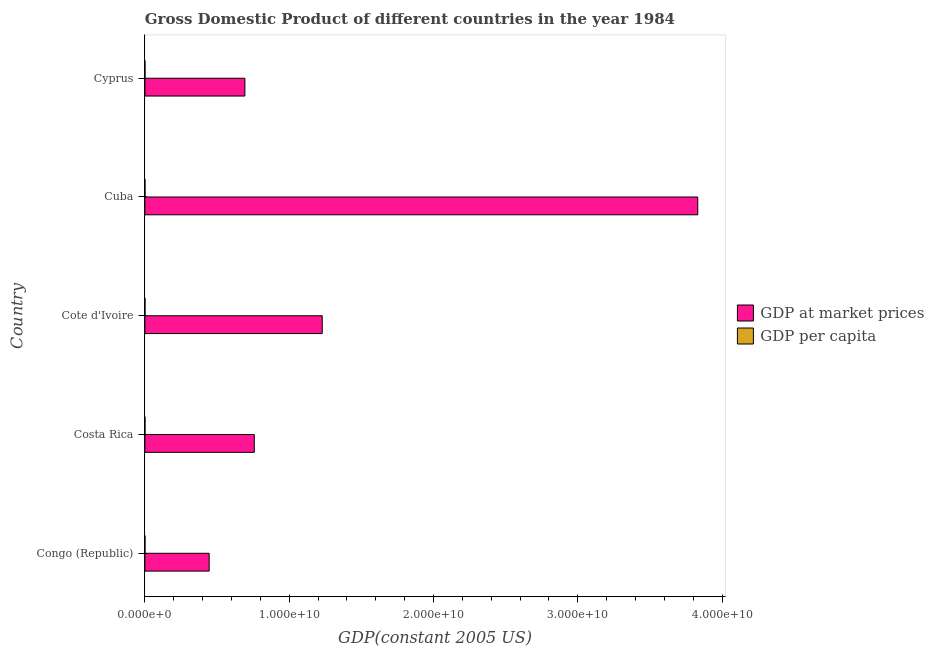How many bars are there on the 1st tick from the top?
Offer a very short reply. 2. How many bars are there on the 4th tick from the bottom?
Offer a terse response. 2. What is the label of the 5th group of bars from the top?
Your answer should be compact. Congo (Republic). What is the gdp at market prices in Congo (Republic)?
Your answer should be very brief. 4.45e+09. Across all countries, what is the maximum gdp at market prices?
Offer a very short reply. 3.83e+1. Across all countries, what is the minimum gdp per capita?
Your answer should be very brief. 1258.08. In which country was the gdp at market prices maximum?
Ensure brevity in your answer.  Cuba. In which country was the gdp per capita minimum?
Your response must be concise. Cote d'Ivoire. What is the total gdp per capita in the graph?
Your answer should be compact. 2.31e+04. What is the difference between the gdp per capita in Costa Rica and that in Cote d'Ivoire?
Make the answer very short. 1592.07. What is the difference between the gdp per capita in Costa Rica and the gdp at market prices in Cote d'Ivoire?
Give a very brief answer. -1.23e+1. What is the average gdp at market prices per country?
Keep it short and to the point. 1.39e+1. What is the difference between the gdp at market prices and gdp per capita in Cote d'Ivoire?
Make the answer very short. 1.23e+1. In how many countries, is the gdp per capita greater than 2000000000 US$?
Offer a very short reply. 0. What is the ratio of the gdp per capita in Cote d'Ivoire to that in Cuba?
Your answer should be very brief. 0.33. Is the gdp per capita in Costa Rica less than that in Cote d'Ivoire?
Ensure brevity in your answer.  No. Is the difference between the gdp per capita in Cote d'Ivoire and Cyprus greater than the difference between the gdp at market prices in Cote d'Ivoire and Cyprus?
Keep it short and to the point. No. What is the difference between the highest and the second highest gdp at market prices?
Your answer should be compact. 2.60e+1. What is the difference between the highest and the lowest gdp at market prices?
Ensure brevity in your answer.  3.39e+1. Is the sum of the gdp at market prices in Cuba and Cyprus greater than the maximum gdp per capita across all countries?
Your answer should be compact. Yes. What does the 1st bar from the top in Cyprus represents?
Your response must be concise. GDP per capita. What does the 2nd bar from the bottom in Congo (Republic) represents?
Keep it short and to the point. GDP per capita. How many bars are there?
Give a very brief answer. 10. Are all the bars in the graph horizontal?
Provide a short and direct response. Yes. How many countries are there in the graph?
Your answer should be very brief. 5. What is the difference between two consecutive major ticks on the X-axis?
Give a very brief answer. 1.00e+1. Are the values on the major ticks of X-axis written in scientific E-notation?
Your answer should be very brief. Yes. Does the graph contain any zero values?
Give a very brief answer. No. Does the graph contain grids?
Make the answer very short. No. Where does the legend appear in the graph?
Your answer should be very brief. Center right. How many legend labels are there?
Offer a terse response. 2. What is the title of the graph?
Ensure brevity in your answer.  Gross Domestic Product of different countries in the year 1984. What is the label or title of the X-axis?
Offer a very short reply. GDP(constant 2005 US). What is the GDP(constant 2005 US) of GDP at market prices in Congo (Republic)?
Your response must be concise. 4.45e+09. What is the GDP(constant 2005 US) in GDP per capita in Congo (Republic)?
Provide a short and direct response. 2198.63. What is the GDP(constant 2005 US) of GDP at market prices in Costa Rica?
Keep it short and to the point. 7.58e+09. What is the GDP(constant 2005 US) in GDP per capita in Costa Rica?
Offer a terse response. 2850.16. What is the GDP(constant 2005 US) in GDP at market prices in Cote d'Ivoire?
Your response must be concise. 1.23e+1. What is the GDP(constant 2005 US) in GDP per capita in Cote d'Ivoire?
Your answer should be very brief. 1258.08. What is the GDP(constant 2005 US) in GDP at market prices in Cuba?
Your response must be concise. 3.83e+1. What is the GDP(constant 2005 US) of GDP per capita in Cuba?
Your response must be concise. 3825.47. What is the GDP(constant 2005 US) in GDP at market prices in Cyprus?
Ensure brevity in your answer.  6.93e+09. What is the GDP(constant 2005 US) in GDP per capita in Cyprus?
Ensure brevity in your answer.  1.30e+04. Across all countries, what is the maximum GDP(constant 2005 US) of GDP at market prices?
Your answer should be very brief. 3.83e+1. Across all countries, what is the maximum GDP(constant 2005 US) in GDP per capita?
Your response must be concise. 1.30e+04. Across all countries, what is the minimum GDP(constant 2005 US) of GDP at market prices?
Keep it short and to the point. 4.45e+09. Across all countries, what is the minimum GDP(constant 2005 US) of GDP per capita?
Give a very brief answer. 1258.08. What is the total GDP(constant 2005 US) in GDP at market prices in the graph?
Your answer should be compact. 6.96e+1. What is the total GDP(constant 2005 US) of GDP per capita in the graph?
Offer a terse response. 2.31e+04. What is the difference between the GDP(constant 2005 US) of GDP at market prices in Congo (Republic) and that in Costa Rica?
Your response must be concise. -3.13e+09. What is the difference between the GDP(constant 2005 US) of GDP per capita in Congo (Republic) and that in Costa Rica?
Offer a very short reply. -651.53. What is the difference between the GDP(constant 2005 US) in GDP at market prices in Congo (Republic) and that in Cote d'Ivoire?
Offer a terse response. -7.84e+09. What is the difference between the GDP(constant 2005 US) in GDP per capita in Congo (Republic) and that in Cote d'Ivoire?
Keep it short and to the point. 940.54. What is the difference between the GDP(constant 2005 US) of GDP at market prices in Congo (Republic) and that in Cuba?
Make the answer very short. -3.39e+1. What is the difference between the GDP(constant 2005 US) in GDP per capita in Congo (Republic) and that in Cuba?
Provide a succinct answer. -1626.84. What is the difference between the GDP(constant 2005 US) of GDP at market prices in Congo (Republic) and that in Cyprus?
Provide a short and direct response. -2.48e+09. What is the difference between the GDP(constant 2005 US) in GDP per capita in Congo (Republic) and that in Cyprus?
Give a very brief answer. -1.08e+04. What is the difference between the GDP(constant 2005 US) in GDP at market prices in Costa Rica and that in Cote d'Ivoire?
Give a very brief answer. -4.71e+09. What is the difference between the GDP(constant 2005 US) in GDP per capita in Costa Rica and that in Cote d'Ivoire?
Provide a short and direct response. 1592.07. What is the difference between the GDP(constant 2005 US) of GDP at market prices in Costa Rica and that in Cuba?
Your answer should be very brief. -3.07e+1. What is the difference between the GDP(constant 2005 US) in GDP per capita in Costa Rica and that in Cuba?
Offer a very short reply. -975.31. What is the difference between the GDP(constant 2005 US) of GDP at market prices in Costa Rica and that in Cyprus?
Your response must be concise. 6.51e+08. What is the difference between the GDP(constant 2005 US) in GDP per capita in Costa Rica and that in Cyprus?
Make the answer very short. -1.01e+04. What is the difference between the GDP(constant 2005 US) of GDP at market prices in Cote d'Ivoire and that in Cuba?
Offer a very short reply. -2.60e+1. What is the difference between the GDP(constant 2005 US) in GDP per capita in Cote d'Ivoire and that in Cuba?
Provide a succinct answer. -2567.38. What is the difference between the GDP(constant 2005 US) of GDP at market prices in Cote d'Ivoire and that in Cyprus?
Offer a very short reply. 5.36e+09. What is the difference between the GDP(constant 2005 US) in GDP per capita in Cote d'Ivoire and that in Cyprus?
Keep it short and to the point. -1.17e+04. What is the difference between the GDP(constant 2005 US) in GDP at market prices in Cuba and that in Cyprus?
Provide a succinct answer. 3.14e+1. What is the difference between the GDP(constant 2005 US) in GDP per capita in Cuba and that in Cyprus?
Your answer should be compact. -9127.99. What is the difference between the GDP(constant 2005 US) in GDP at market prices in Congo (Republic) and the GDP(constant 2005 US) in GDP per capita in Costa Rica?
Your response must be concise. 4.45e+09. What is the difference between the GDP(constant 2005 US) of GDP at market prices in Congo (Republic) and the GDP(constant 2005 US) of GDP per capita in Cote d'Ivoire?
Ensure brevity in your answer.  4.45e+09. What is the difference between the GDP(constant 2005 US) of GDP at market prices in Congo (Republic) and the GDP(constant 2005 US) of GDP per capita in Cuba?
Give a very brief answer. 4.45e+09. What is the difference between the GDP(constant 2005 US) of GDP at market prices in Congo (Republic) and the GDP(constant 2005 US) of GDP per capita in Cyprus?
Provide a succinct answer. 4.45e+09. What is the difference between the GDP(constant 2005 US) of GDP at market prices in Costa Rica and the GDP(constant 2005 US) of GDP per capita in Cote d'Ivoire?
Keep it short and to the point. 7.58e+09. What is the difference between the GDP(constant 2005 US) in GDP at market prices in Costa Rica and the GDP(constant 2005 US) in GDP per capita in Cuba?
Ensure brevity in your answer.  7.58e+09. What is the difference between the GDP(constant 2005 US) in GDP at market prices in Costa Rica and the GDP(constant 2005 US) in GDP per capita in Cyprus?
Make the answer very short. 7.58e+09. What is the difference between the GDP(constant 2005 US) in GDP at market prices in Cote d'Ivoire and the GDP(constant 2005 US) in GDP per capita in Cuba?
Provide a short and direct response. 1.23e+1. What is the difference between the GDP(constant 2005 US) in GDP at market prices in Cote d'Ivoire and the GDP(constant 2005 US) in GDP per capita in Cyprus?
Give a very brief answer. 1.23e+1. What is the difference between the GDP(constant 2005 US) of GDP at market prices in Cuba and the GDP(constant 2005 US) of GDP per capita in Cyprus?
Ensure brevity in your answer.  3.83e+1. What is the average GDP(constant 2005 US) in GDP at market prices per country?
Ensure brevity in your answer.  1.39e+1. What is the average GDP(constant 2005 US) of GDP per capita per country?
Your answer should be very brief. 4617.16. What is the difference between the GDP(constant 2005 US) in GDP at market prices and GDP(constant 2005 US) in GDP per capita in Congo (Republic)?
Keep it short and to the point. 4.45e+09. What is the difference between the GDP(constant 2005 US) in GDP at market prices and GDP(constant 2005 US) in GDP per capita in Costa Rica?
Make the answer very short. 7.58e+09. What is the difference between the GDP(constant 2005 US) in GDP at market prices and GDP(constant 2005 US) in GDP per capita in Cote d'Ivoire?
Your answer should be compact. 1.23e+1. What is the difference between the GDP(constant 2005 US) in GDP at market prices and GDP(constant 2005 US) in GDP per capita in Cuba?
Give a very brief answer. 3.83e+1. What is the difference between the GDP(constant 2005 US) of GDP at market prices and GDP(constant 2005 US) of GDP per capita in Cyprus?
Provide a short and direct response. 6.93e+09. What is the ratio of the GDP(constant 2005 US) of GDP at market prices in Congo (Republic) to that in Costa Rica?
Keep it short and to the point. 0.59. What is the ratio of the GDP(constant 2005 US) of GDP per capita in Congo (Republic) to that in Costa Rica?
Provide a short and direct response. 0.77. What is the ratio of the GDP(constant 2005 US) of GDP at market prices in Congo (Republic) to that in Cote d'Ivoire?
Your answer should be compact. 0.36. What is the ratio of the GDP(constant 2005 US) in GDP per capita in Congo (Republic) to that in Cote d'Ivoire?
Offer a terse response. 1.75. What is the ratio of the GDP(constant 2005 US) in GDP at market prices in Congo (Republic) to that in Cuba?
Your answer should be very brief. 0.12. What is the ratio of the GDP(constant 2005 US) in GDP per capita in Congo (Republic) to that in Cuba?
Your response must be concise. 0.57. What is the ratio of the GDP(constant 2005 US) of GDP at market prices in Congo (Republic) to that in Cyprus?
Provide a succinct answer. 0.64. What is the ratio of the GDP(constant 2005 US) in GDP per capita in Congo (Republic) to that in Cyprus?
Your answer should be very brief. 0.17. What is the ratio of the GDP(constant 2005 US) of GDP at market prices in Costa Rica to that in Cote d'Ivoire?
Give a very brief answer. 0.62. What is the ratio of the GDP(constant 2005 US) in GDP per capita in Costa Rica to that in Cote d'Ivoire?
Your response must be concise. 2.27. What is the ratio of the GDP(constant 2005 US) of GDP at market prices in Costa Rica to that in Cuba?
Make the answer very short. 0.2. What is the ratio of the GDP(constant 2005 US) of GDP per capita in Costa Rica to that in Cuba?
Make the answer very short. 0.74. What is the ratio of the GDP(constant 2005 US) of GDP at market prices in Costa Rica to that in Cyprus?
Your answer should be very brief. 1.09. What is the ratio of the GDP(constant 2005 US) of GDP per capita in Costa Rica to that in Cyprus?
Keep it short and to the point. 0.22. What is the ratio of the GDP(constant 2005 US) of GDP at market prices in Cote d'Ivoire to that in Cuba?
Offer a very short reply. 0.32. What is the ratio of the GDP(constant 2005 US) in GDP per capita in Cote d'Ivoire to that in Cuba?
Give a very brief answer. 0.33. What is the ratio of the GDP(constant 2005 US) in GDP at market prices in Cote d'Ivoire to that in Cyprus?
Provide a succinct answer. 1.77. What is the ratio of the GDP(constant 2005 US) of GDP per capita in Cote d'Ivoire to that in Cyprus?
Give a very brief answer. 0.1. What is the ratio of the GDP(constant 2005 US) of GDP at market prices in Cuba to that in Cyprus?
Your response must be concise. 5.53. What is the ratio of the GDP(constant 2005 US) in GDP per capita in Cuba to that in Cyprus?
Make the answer very short. 0.3. What is the difference between the highest and the second highest GDP(constant 2005 US) in GDP at market prices?
Offer a very short reply. 2.60e+1. What is the difference between the highest and the second highest GDP(constant 2005 US) in GDP per capita?
Your answer should be very brief. 9127.99. What is the difference between the highest and the lowest GDP(constant 2005 US) in GDP at market prices?
Offer a very short reply. 3.39e+1. What is the difference between the highest and the lowest GDP(constant 2005 US) in GDP per capita?
Give a very brief answer. 1.17e+04. 